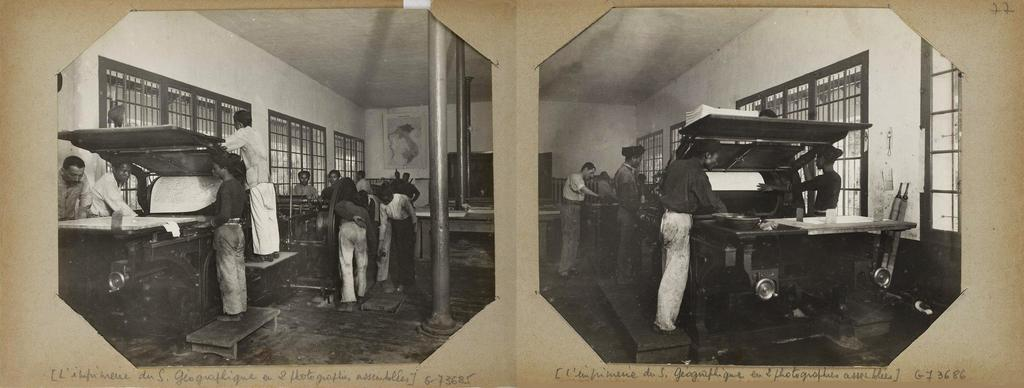What type of images are present in the image? There are two black and white photos in the image. How are the photos displayed in the image? The photos are pasted on a card. Are there any words on the card? Yes, there are words on the card. What type of attraction can be seen in the background of the image? There is no attraction visible in the image; it only contains two black and white photos pasted on a card with words. How many balloons are present in the image? There are no balloons present in the image. 